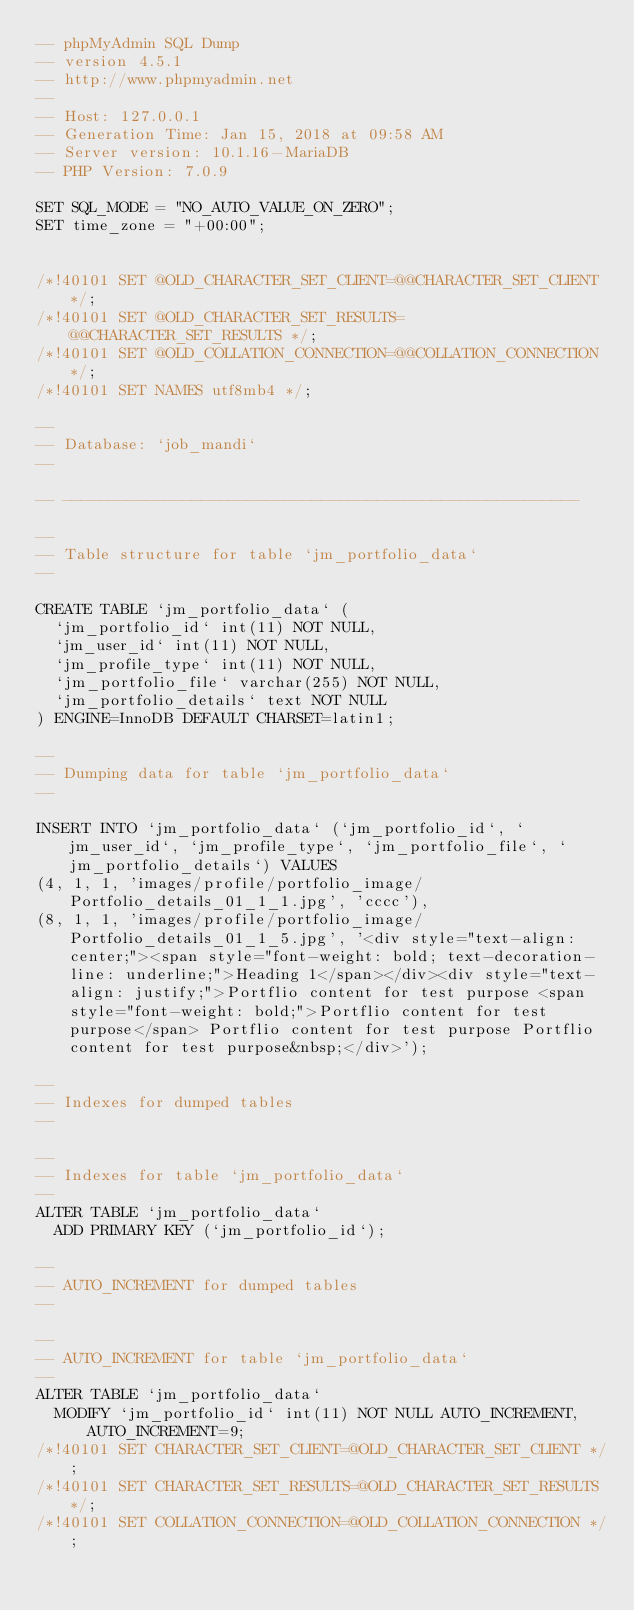<code> <loc_0><loc_0><loc_500><loc_500><_SQL_>-- phpMyAdmin SQL Dump
-- version 4.5.1
-- http://www.phpmyadmin.net
--
-- Host: 127.0.0.1
-- Generation Time: Jan 15, 2018 at 09:58 AM
-- Server version: 10.1.16-MariaDB
-- PHP Version: 7.0.9

SET SQL_MODE = "NO_AUTO_VALUE_ON_ZERO";
SET time_zone = "+00:00";


/*!40101 SET @OLD_CHARACTER_SET_CLIENT=@@CHARACTER_SET_CLIENT */;
/*!40101 SET @OLD_CHARACTER_SET_RESULTS=@@CHARACTER_SET_RESULTS */;
/*!40101 SET @OLD_COLLATION_CONNECTION=@@COLLATION_CONNECTION */;
/*!40101 SET NAMES utf8mb4 */;

--
-- Database: `job_mandi`
--

-- --------------------------------------------------------

--
-- Table structure for table `jm_portfolio_data`
--

CREATE TABLE `jm_portfolio_data` (
  `jm_portfolio_id` int(11) NOT NULL,
  `jm_user_id` int(11) NOT NULL,
  `jm_profile_type` int(11) NOT NULL,
  `jm_portfolio_file` varchar(255) NOT NULL,
  `jm_portfolio_details` text NOT NULL
) ENGINE=InnoDB DEFAULT CHARSET=latin1;

--
-- Dumping data for table `jm_portfolio_data`
--

INSERT INTO `jm_portfolio_data` (`jm_portfolio_id`, `jm_user_id`, `jm_profile_type`, `jm_portfolio_file`, `jm_portfolio_details`) VALUES
(4, 1, 1, 'images/profile/portfolio_image/Portfolio_details_01_1_1.jpg', 'cccc'),
(8, 1, 1, 'images/profile/portfolio_image/Portfolio_details_01_1_5.jpg', '<div style="text-align: center;"><span style="font-weight: bold; text-decoration-line: underline;">Heading 1</span></div><div style="text-align: justify;">Portflio content for test purpose <span style="font-weight: bold;">Portflio content for test purpose</span> Portflio content for test purpose Portflio content for test purpose&nbsp;</div>');

--
-- Indexes for dumped tables
--

--
-- Indexes for table `jm_portfolio_data`
--
ALTER TABLE `jm_portfolio_data`
  ADD PRIMARY KEY (`jm_portfolio_id`);

--
-- AUTO_INCREMENT for dumped tables
--

--
-- AUTO_INCREMENT for table `jm_portfolio_data`
--
ALTER TABLE `jm_portfolio_data`
  MODIFY `jm_portfolio_id` int(11) NOT NULL AUTO_INCREMENT, AUTO_INCREMENT=9;
/*!40101 SET CHARACTER_SET_CLIENT=@OLD_CHARACTER_SET_CLIENT */;
/*!40101 SET CHARACTER_SET_RESULTS=@OLD_CHARACTER_SET_RESULTS */;
/*!40101 SET COLLATION_CONNECTION=@OLD_COLLATION_CONNECTION */;
</code> 